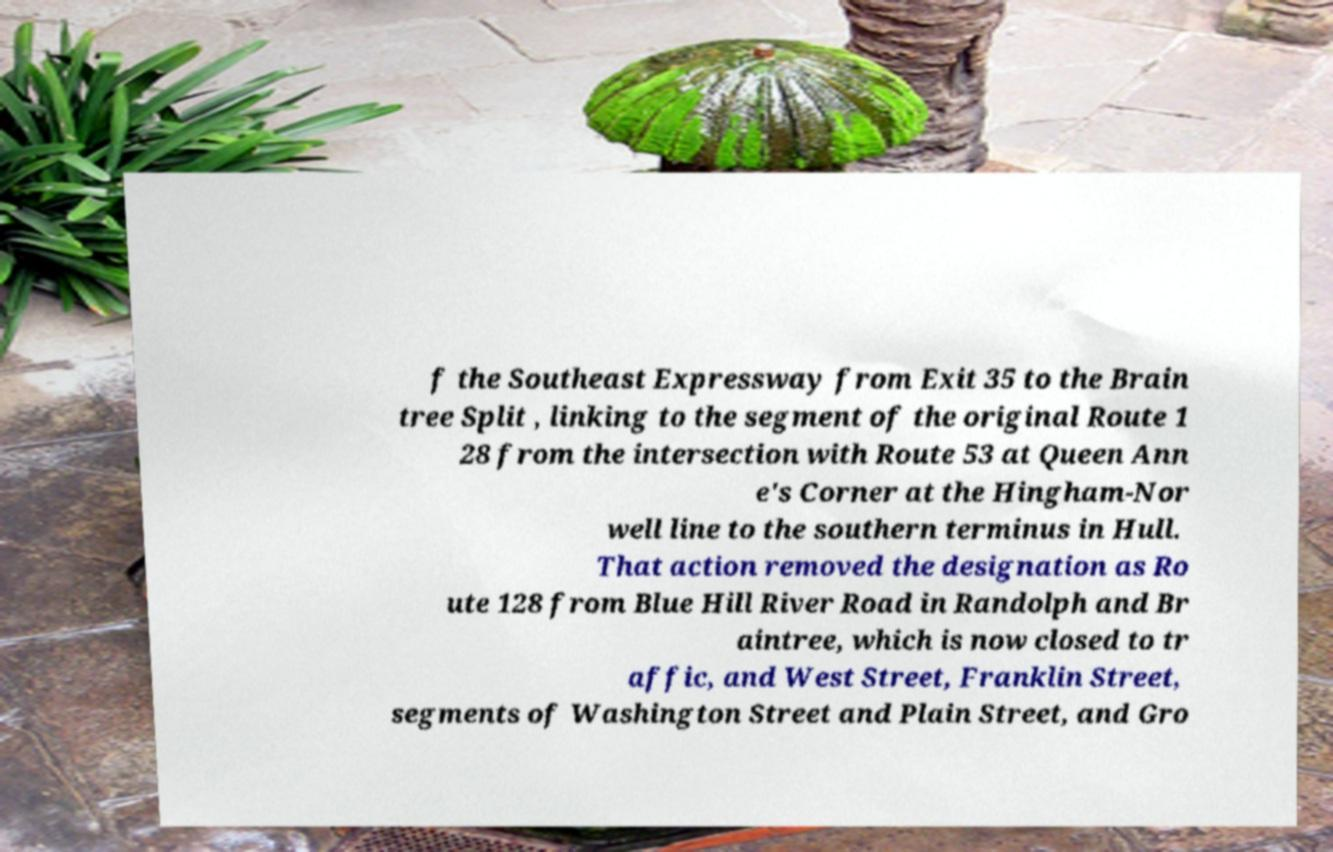Please identify and transcribe the text found in this image. f the Southeast Expressway from Exit 35 to the Brain tree Split , linking to the segment of the original Route 1 28 from the intersection with Route 53 at Queen Ann e's Corner at the Hingham-Nor well line to the southern terminus in Hull. That action removed the designation as Ro ute 128 from Blue Hill River Road in Randolph and Br aintree, which is now closed to tr affic, and West Street, Franklin Street, segments of Washington Street and Plain Street, and Gro 